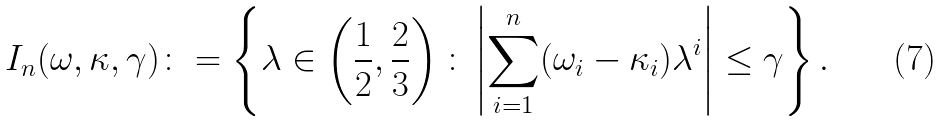Convert formula to latex. <formula><loc_0><loc_0><loc_500><loc_500>I _ { n } ( \omega , \kappa , \gamma ) \colon = \left \{ \lambda \in \left ( \frac { 1 } { 2 } , \frac { 2 } { 3 } \right ) \colon \left | \sum _ { i = 1 } ^ { n } ( \omega _ { i } - \kappa _ { i } ) \lambda ^ { i } \right | \leq \gamma \right \} .</formula> 